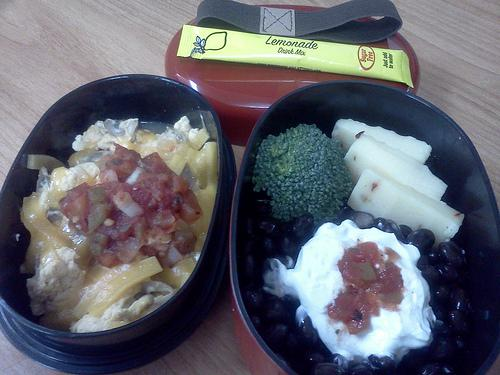Question: what color is the broccoli?
Choices:
A. Blue.
B. Yellow.
C. Green.
D. Brown.
Answer with the letter. Answer: C Question: what color is the salsa?
Choices:
A. Red.
B. Green.
C. Pink.
D. Brown.
Answer with the letter. Answer: A 